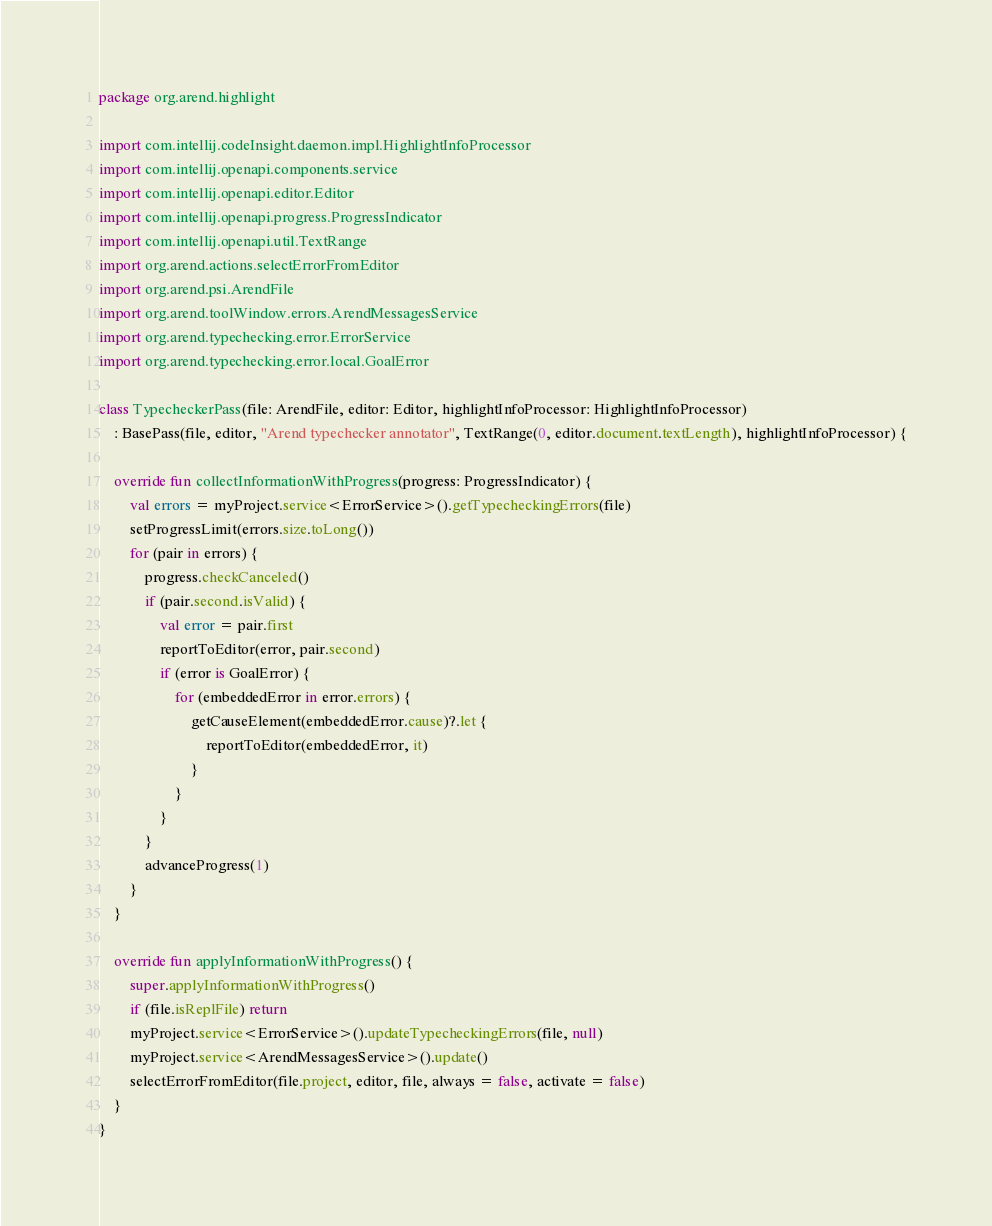Convert code to text. <code><loc_0><loc_0><loc_500><loc_500><_Kotlin_>package org.arend.highlight

import com.intellij.codeInsight.daemon.impl.HighlightInfoProcessor
import com.intellij.openapi.components.service
import com.intellij.openapi.editor.Editor
import com.intellij.openapi.progress.ProgressIndicator
import com.intellij.openapi.util.TextRange
import org.arend.actions.selectErrorFromEditor
import org.arend.psi.ArendFile
import org.arend.toolWindow.errors.ArendMessagesService
import org.arend.typechecking.error.ErrorService
import org.arend.typechecking.error.local.GoalError

class TypecheckerPass(file: ArendFile, editor: Editor, highlightInfoProcessor: HighlightInfoProcessor)
    : BasePass(file, editor, "Arend typechecker annotator", TextRange(0, editor.document.textLength), highlightInfoProcessor) {

    override fun collectInformationWithProgress(progress: ProgressIndicator) {
        val errors = myProject.service<ErrorService>().getTypecheckingErrors(file)
        setProgressLimit(errors.size.toLong())
        for (pair in errors) {
            progress.checkCanceled()
            if (pair.second.isValid) {
                val error = pair.first
                reportToEditor(error, pair.second)
                if (error is GoalError) {
                    for (embeddedError in error.errors) {
                        getCauseElement(embeddedError.cause)?.let {
                            reportToEditor(embeddedError, it)
                        }
                    }
                }
            }
            advanceProgress(1)
        }
    }

    override fun applyInformationWithProgress() {
        super.applyInformationWithProgress()
        if (file.isReplFile) return
        myProject.service<ErrorService>().updateTypecheckingErrors(file, null)
        myProject.service<ArendMessagesService>().update()
        selectErrorFromEditor(file.project, editor, file, always = false, activate = false)
    }
}</code> 